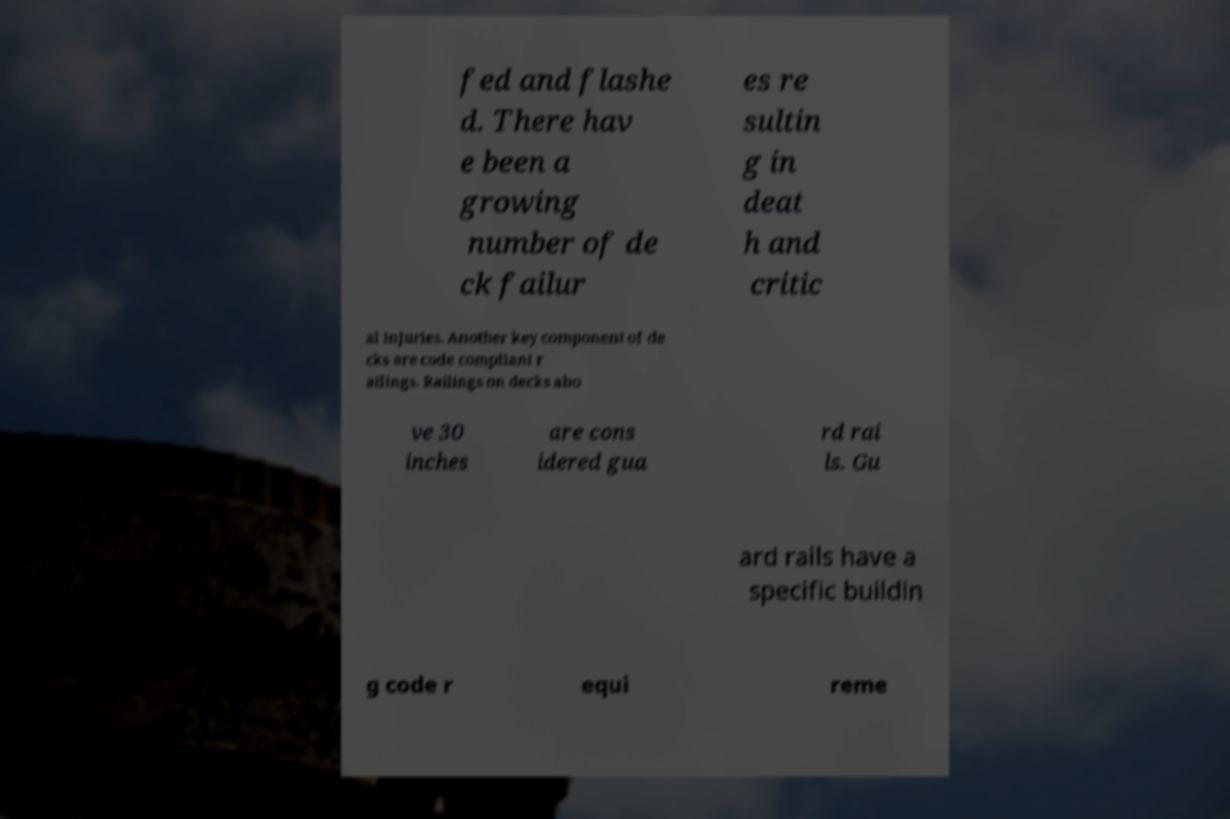For documentation purposes, I need the text within this image transcribed. Could you provide that? fed and flashe d. There hav e been a growing number of de ck failur es re sultin g in deat h and critic al injuries. Another key component of de cks are code compliant r ailings. Railings on decks abo ve 30 inches are cons idered gua rd rai ls. Gu ard rails have a specific buildin g code r equi reme 